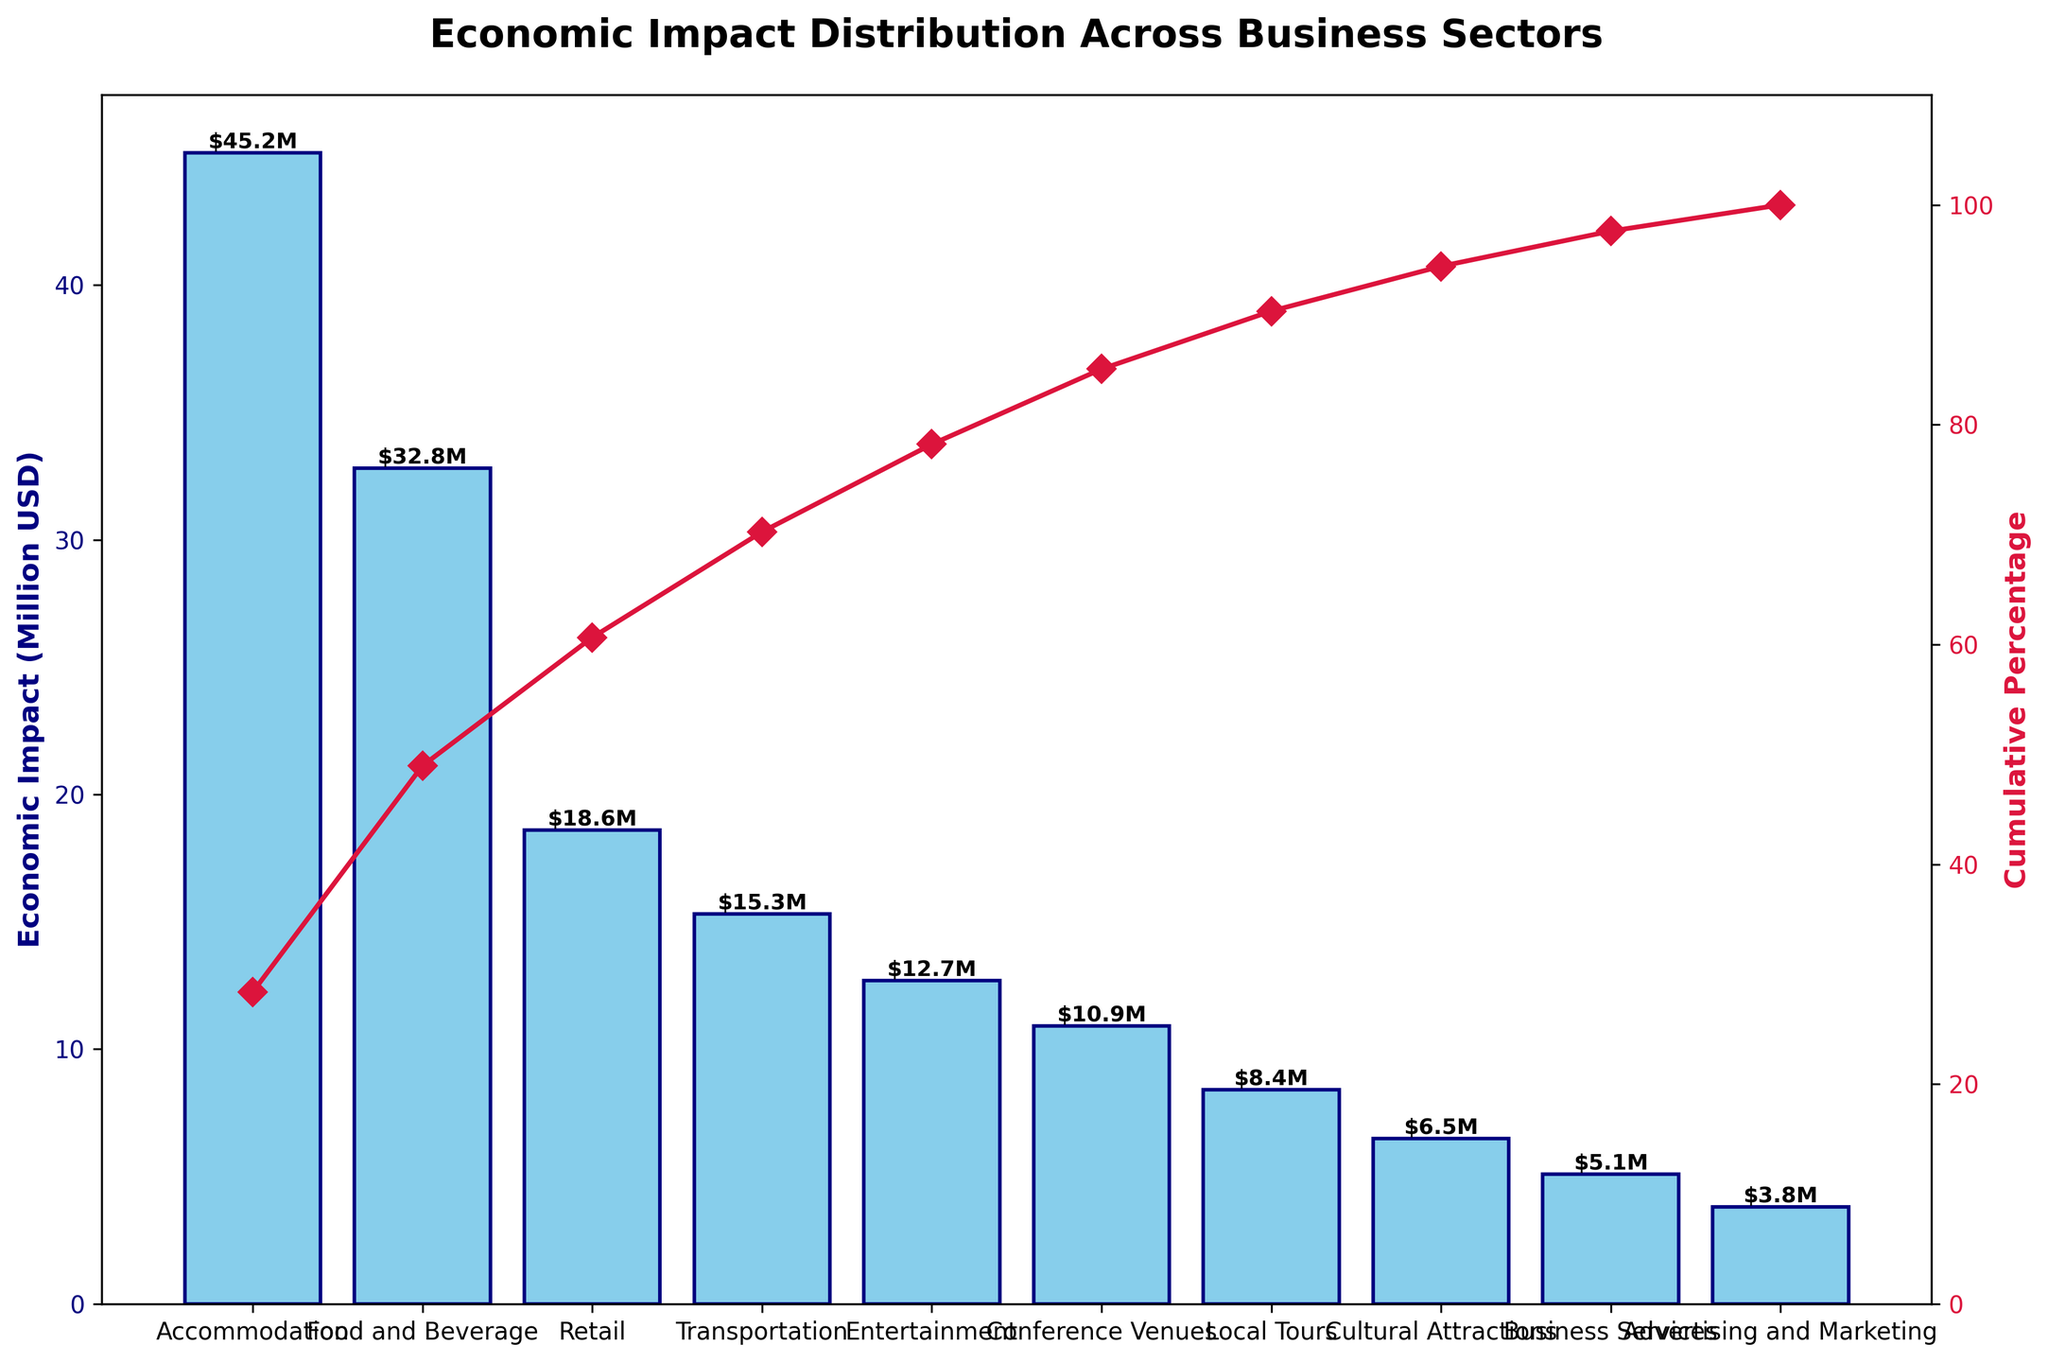What is the title of the figure? The title of the figure is usually located at the top and directly explains what the chart is about. Here, it is specific to the economic impact across different business sectors.
Answer: Economic Impact Distribution Across Business Sectors What sector has the highest economic impact? The tallest bar in the graph represents the sector with the highest economic impact. Here, it is labeled “Accommodation”.
Answer: Accommodation Which sector contributes the least to the economic impact? The shortest bar in the graph shows the sector with the least economic impact. Here, it is labeled “Advertising and Marketing”.
Answer: Advertising and Marketing What is the cumulative percentage contribution of the top three sectors? Identify the top three sectors by their bar heights (Accommodation, Food and Beverage, Retail), then look at the cumulative percentage line corresponding to the third sector (Retail).
Answer: Approximately 77% How much more economic impact does the Accommodation sector have compared to Business Services? Find the heights of the bars for both Accommodation and Business Services. Subtract the smaller value (Business Services) from the larger value (Accommodation).
Answer: $40.1M How many sectors contribute to reaching a cumulative percentage of around 90%? Follow the cumulative percentage line until it reaches near 90%, then count the number of sectors corresponding to this point.
Answer: 8 sectors What is the cumulative percentage after including the Food and Beverage sector? Observe where the cumulative percentage line crosses the label for the Food and Beverage sector.
Answer: Approximately 56% Which two sectors combined have an economic impact closest to $50 million? Look for sector bars that together sum closest to $50M. For instance, Retail and Transportation: $18.6M + $15.3M.
Answer: Retail and Transportation What is the economic impact contribution of the Conference Venues sector? The height of the bar labeled "Conference Venues" provides this information.
Answer: $10.9M Which sector sees the steepest increase in the cumulative percentage line? Identify the sector where the red cumulative percentage line has the sharpest upward slope. This occurs typically after a high economic impact sector, here it is "Accommodation".
Answer: Accommodation 